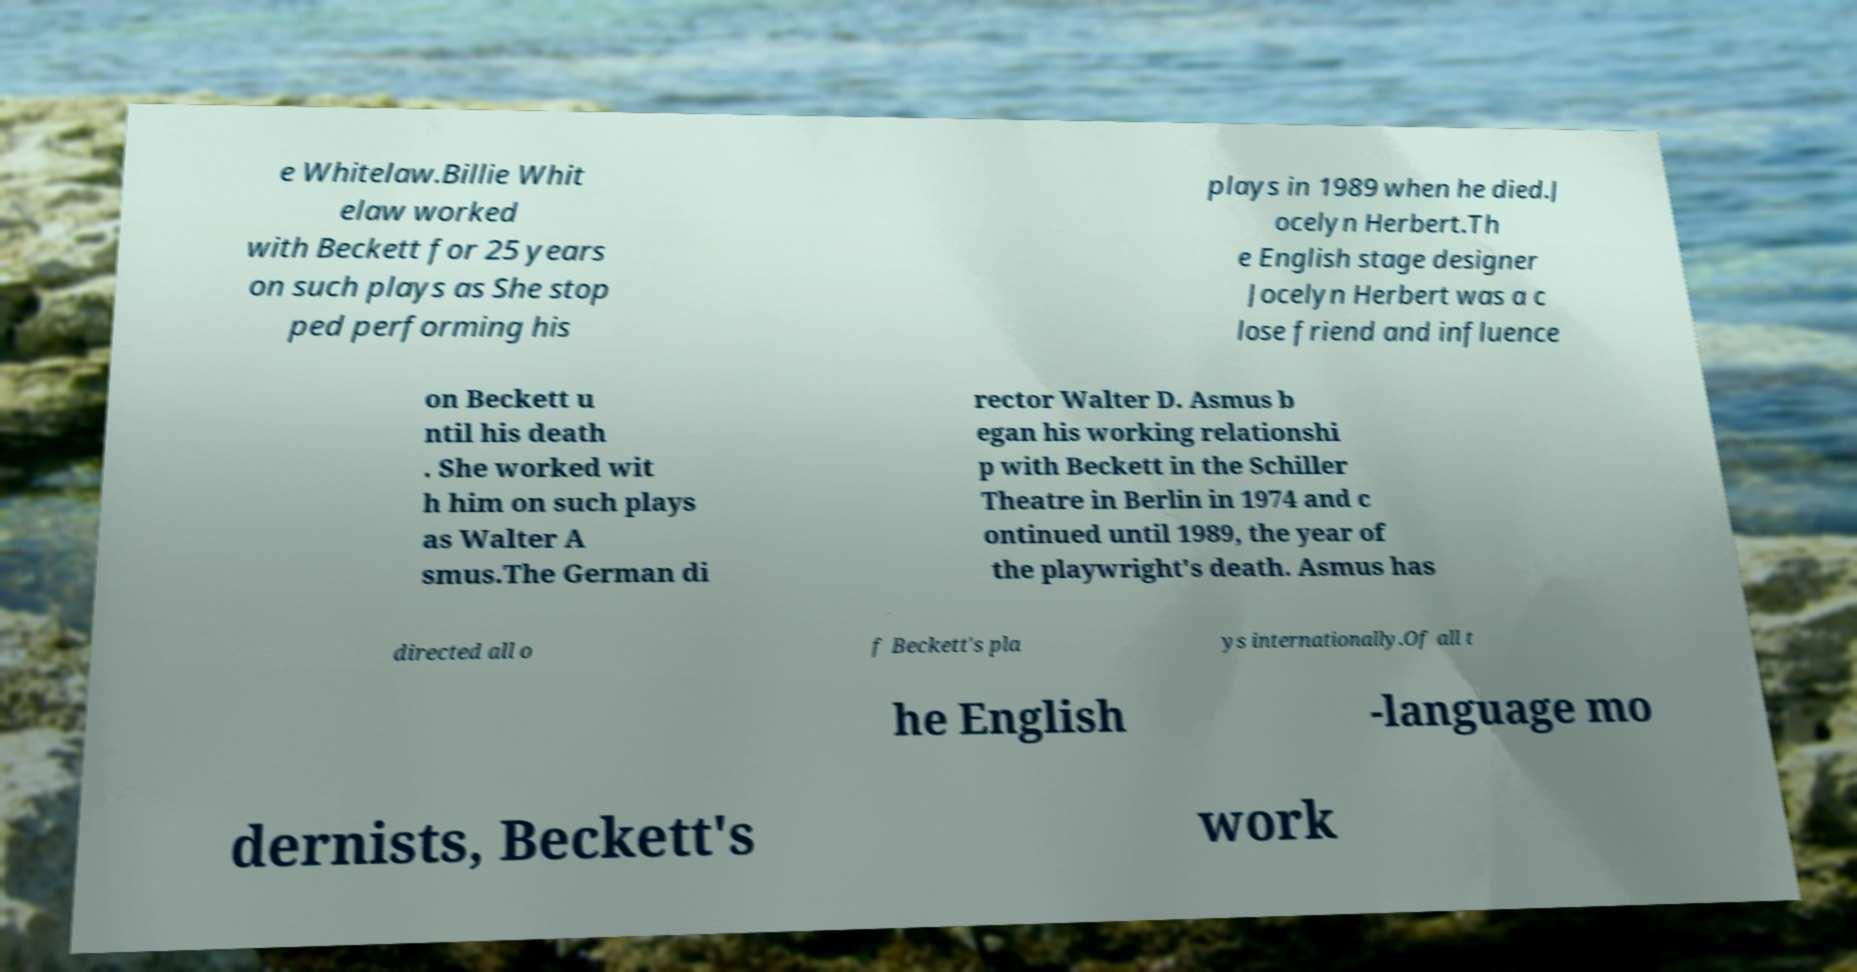Please read and relay the text visible in this image. What does it say? e Whitelaw.Billie Whit elaw worked with Beckett for 25 years on such plays as She stop ped performing his plays in 1989 when he died.J ocelyn Herbert.Th e English stage designer Jocelyn Herbert was a c lose friend and influence on Beckett u ntil his death . She worked wit h him on such plays as Walter A smus.The German di rector Walter D. Asmus b egan his working relationshi p with Beckett in the Schiller Theatre in Berlin in 1974 and c ontinued until 1989, the year of the playwright's death. Asmus has directed all o f Beckett's pla ys internationally.Of all t he English -language mo dernists, Beckett's work 